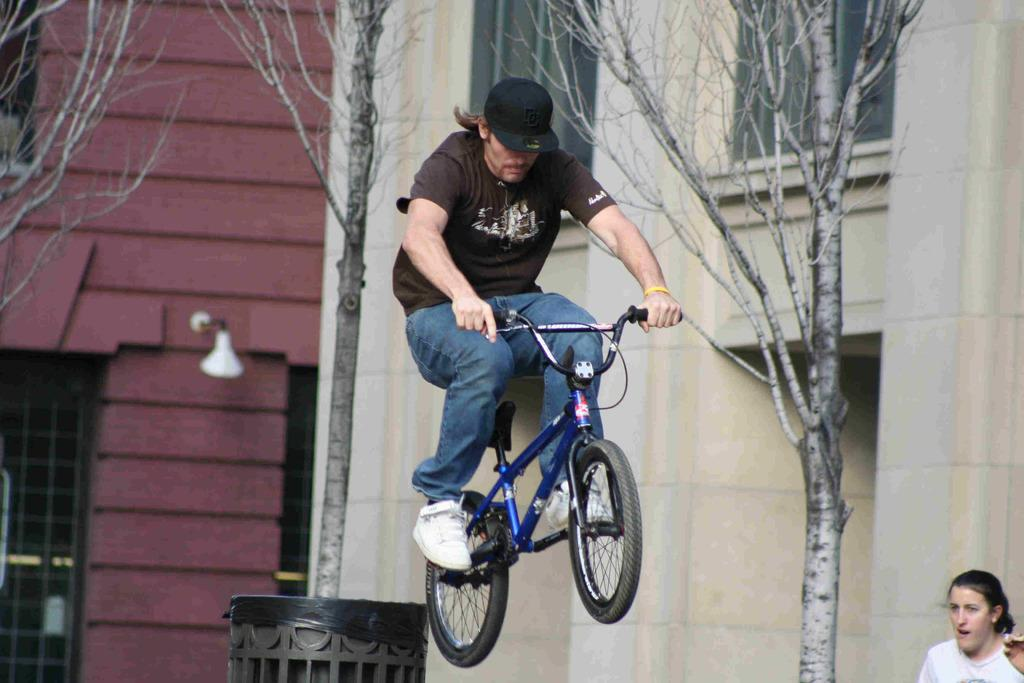What is the man in the image wearing on his head? The man is wearing a cap. What type of footwear is the man wearing in the image? The man is wearing shoes. What is the man holding in the image? The man is holding a bicycle with his hand. What is the man's position in the image? The man appears to be in the air. What type of vegetation can be seen in the image? There are trees in the image. What type of structure is visible in the image? There is a building with windows in the image. What architectural feature is present in the image? There is a wall in the image. What type of container is present in the image? There is a bin in the image. Are there any other people in the image besides the man? Yes, there is a woman in the image. What type of plantation can be seen in the image? There is no plantation present in the image. What detail on the man's shoes can be seen in the image? The provided facts do not mention any specific details about the shoes, so it cannot be determined from the image. 